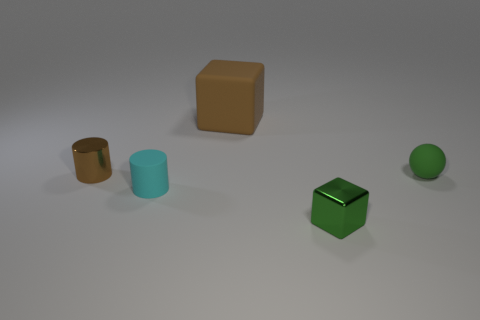Add 4 small brown cylinders. How many objects exist? 9 Subtract all cubes. How many objects are left? 3 Subtract 1 brown blocks. How many objects are left? 4 Subtract all tiny purple matte spheres. Subtract all large brown rubber blocks. How many objects are left? 4 Add 4 small brown cylinders. How many small brown cylinders are left? 5 Add 3 green objects. How many green objects exist? 5 